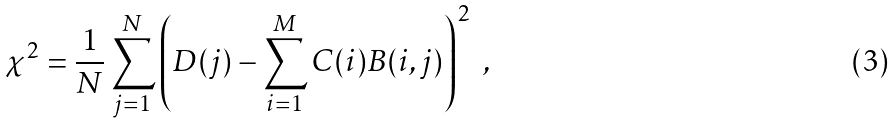<formula> <loc_0><loc_0><loc_500><loc_500>\chi ^ { 2 } = \frac { 1 } { N } \sum _ { j = 1 } ^ { N } \left ( D ( j ) - \sum _ { i = 1 } ^ { M } C ( i ) B ( i , j ) \right ) ^ { 2 } \ ,</formula> 